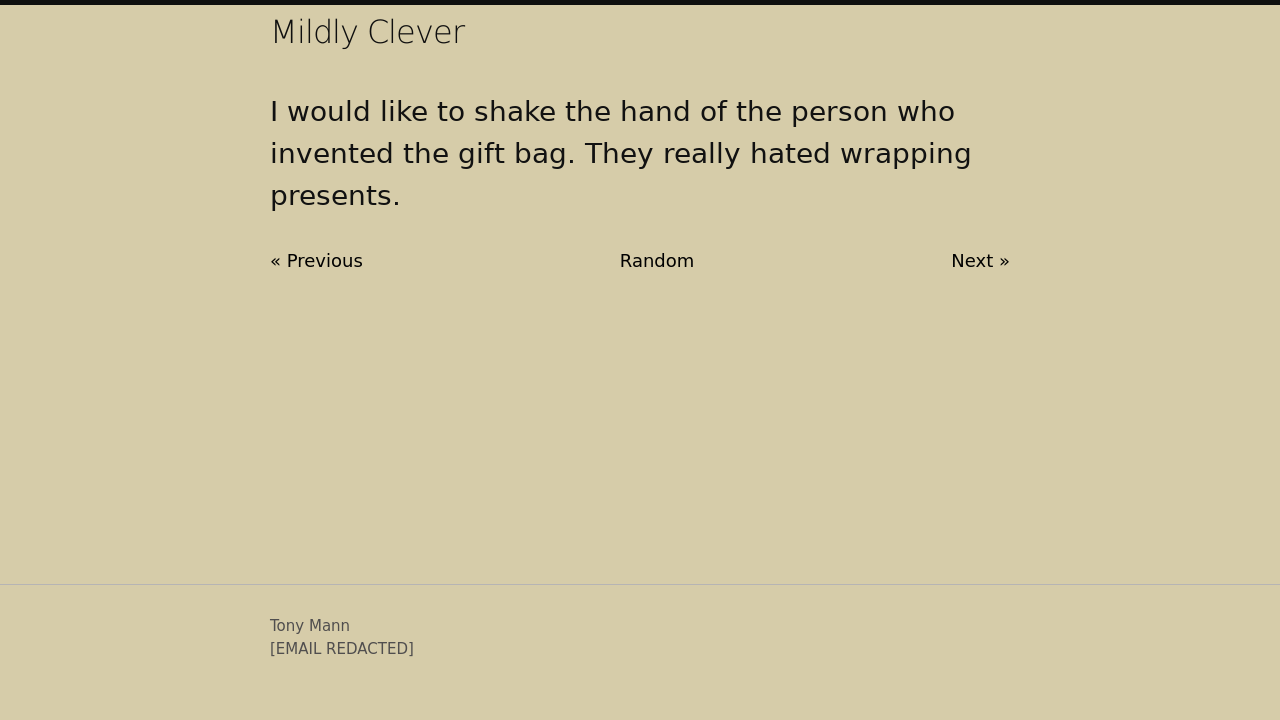What are some creative uses for gift bags besides their usual purpose? Gift bags can be repurposed in several creative ways. They can serve as decorative storage for items like stationary, act as plant holders, or be used to organize small items in a closet or drawer. Additionally, some people use them as travel shoe bags or to wrap multiple small gifts in one package.  Are there any notable trends in gift bag designs? Recent trends in gift bag designs include eco-friendly materials, such as biodegradable or recycled paper. There's also a movement towards minimalist aesthetics with simple patterns and muted colors, alongside a rise in personalized bags that cater to specific holidays or life events, providing a more custom and thoughtful packaging option. 